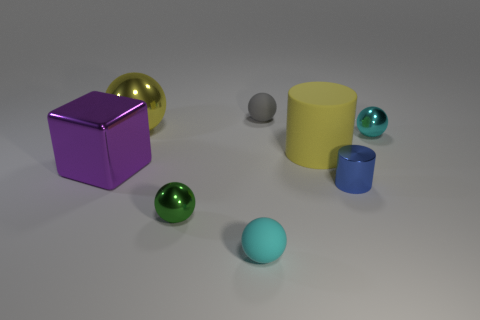What number of shiny things are the same size as the shiny cylinder?
Your answer should be very brief. 2. Are there fewer tiny cyan rubber objects on the left side of the purple shiny block than shiny balls that are to the right of the cyan shiny thing?
Make the answer very short. No. How big is the matte object that is in front of the big shiny object left of the large yellow sphere that is behind the tiny blue cylinder?
Your answer should be compact. Small. There is a thing that is both to the left of the small green metallic thing and on the right side of the purple cube; what size is it?
Ensure brevity in your answer.  Large. What shape is the large shiny thing that is in front of the small cyan thing that is behind the purple metal thing?
Ensure brevity in your answer.  Cube. Is there any other thing that has the same color as the big metallic cube?
Provide a short and direct response. No. There is a rubber thing that is behind the large yellow matte thing; what shape is it?
Provide a succinct answer. Sphere. There is a metallic object that is both to the left of the blue metal thing and behind the big cylinder; what is its shape?
Give a very brief answer. Sphere. What number of cyan things are small things or balls?
Offer a very short reply. 2. Is the color of the big object that is behind the yellow matte object the same as the large matte object?
Make the answer very short. Yes. 